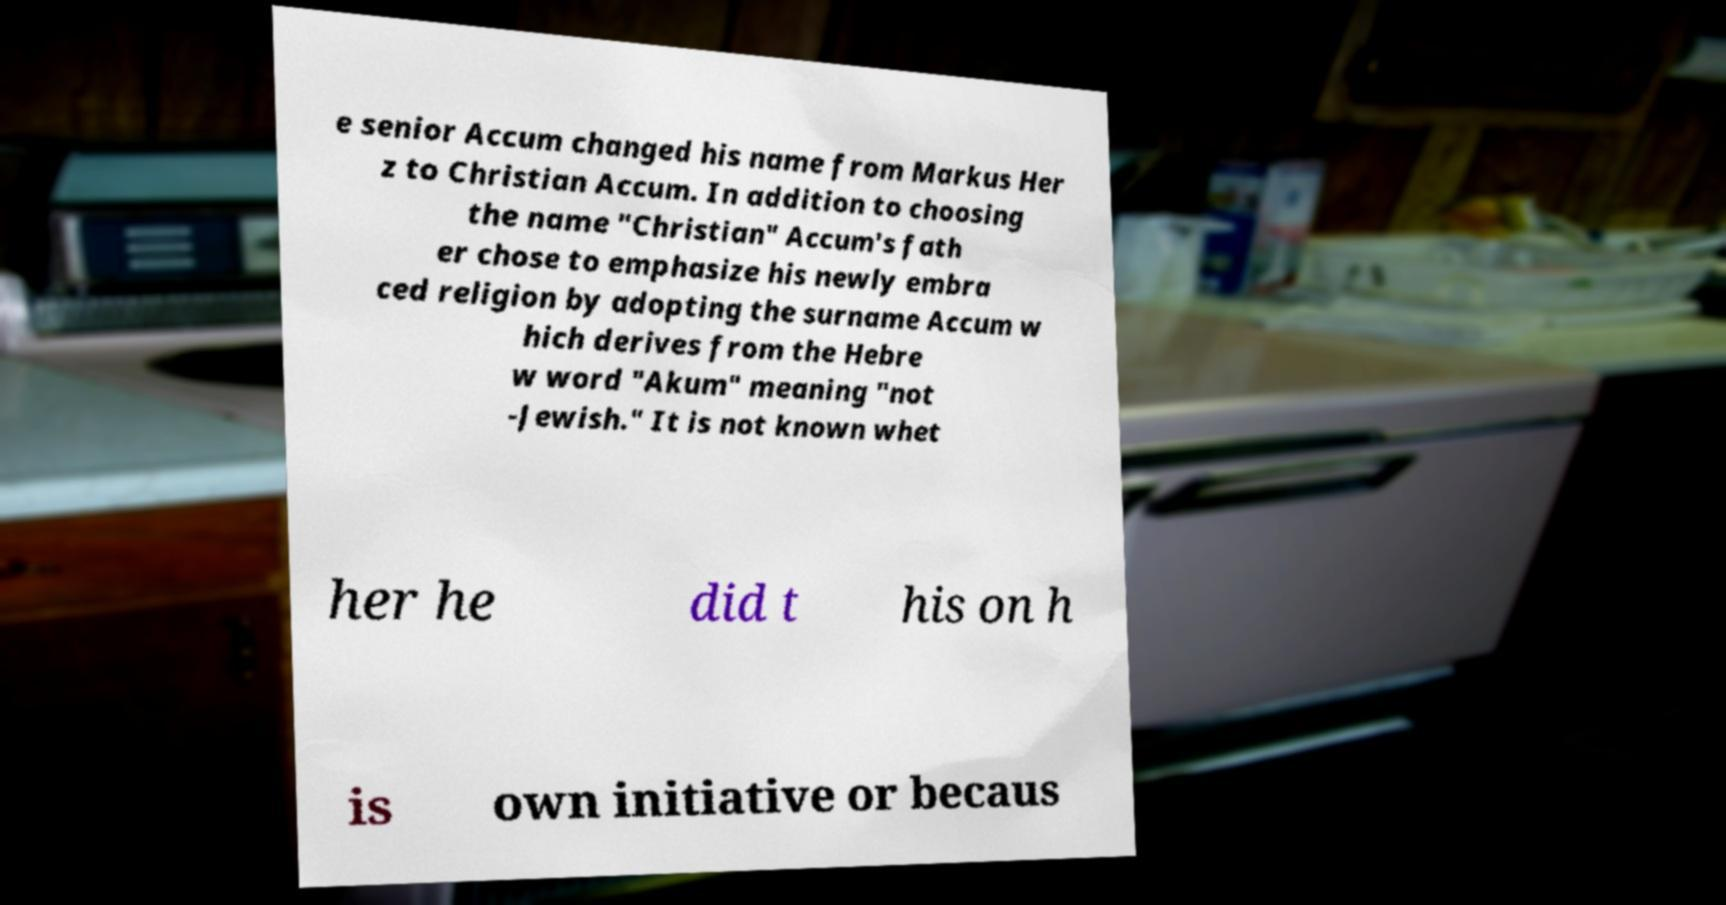I need the written content from this picture converted into text. Can you do that? e senior Accum changed his name from Markus Her z to Christian Accum. In addition to choosing the name "Christian" Accum's fath er chose to emphasize his newly embra ced religion by adopting the surname Accum w hich derives from the Hebre w word "Akum" meaning "not -Jewish." It is not known whet her he did t his on h is own initiative or becaus 